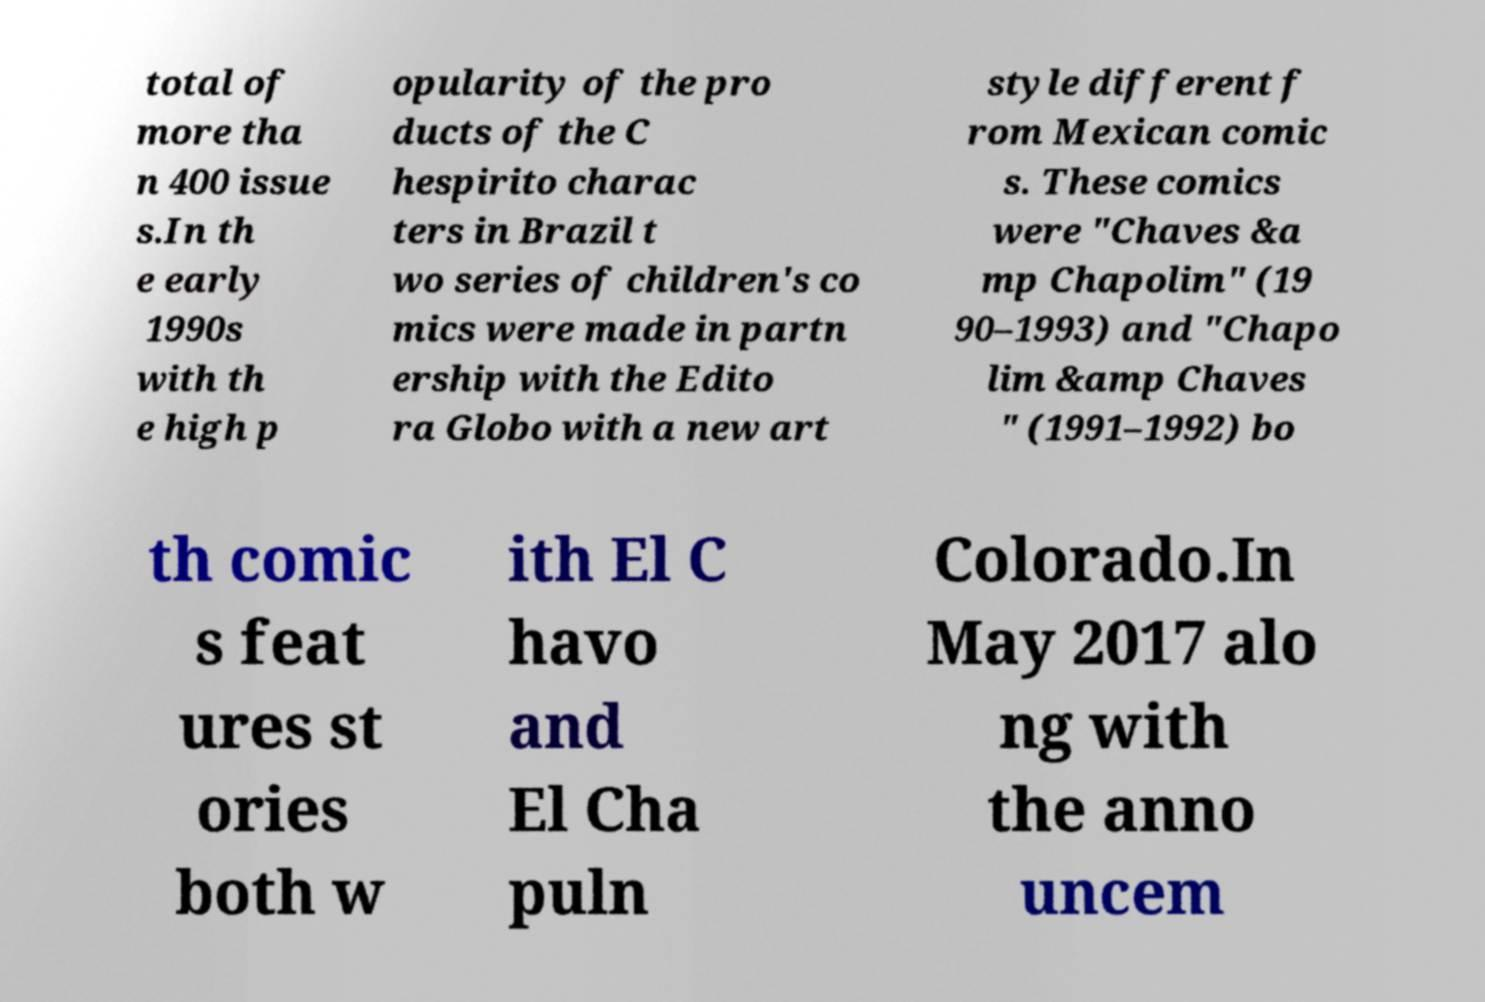What messages or text are displayed in this image? I need them in a readable, typed format. total of more tha n 400 issue s.In th e early 1990s with th e high p opularity of the pro ducts of the C hespirito charac ters in Brazil t wo series of children's co mics were made in partn ership with the Edito ra Globo with a new art style different f rom Mexican comic s. These comics were "Chaves &a mp Chapolim" (19 90–1993) and "Chapo lim &amp Chaves " (1991–1992) bo th comic s feat ures st ories both w ith El C havo and El Cha puln Colorado.In May 2017 alo ng with the anno uncem 